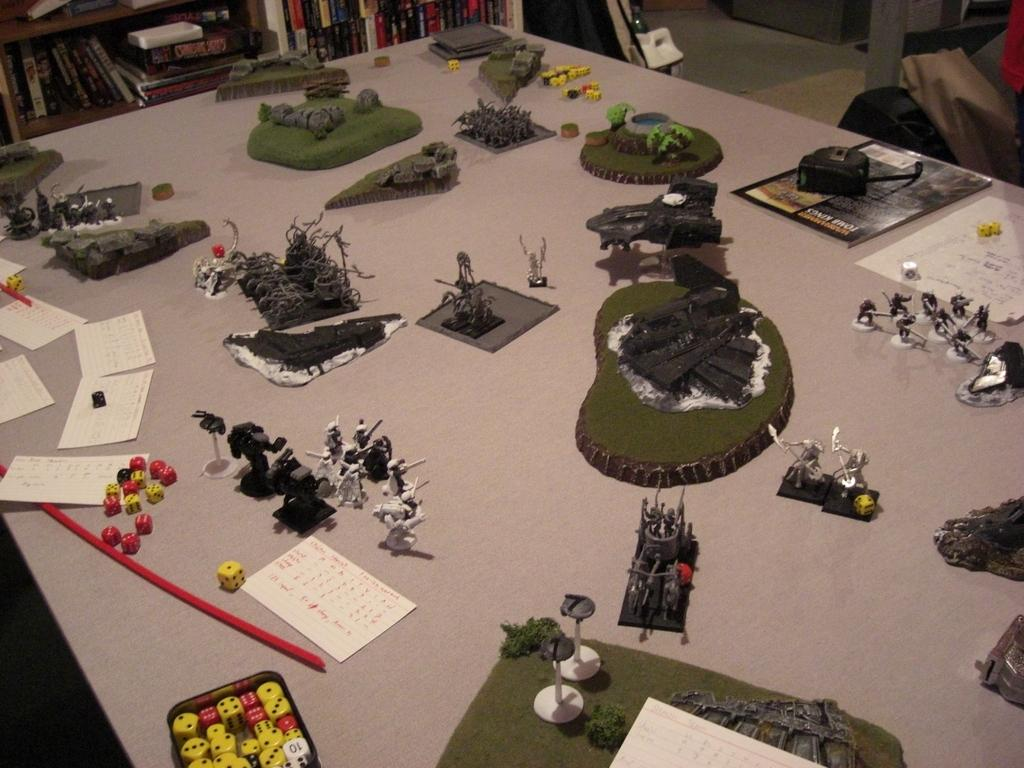What is the primary surface where objects are placed in the image? There are objects placed on a table in the image. What can be seen in the background of the image? There is a bookshelf in the background of the image. How many dogs are sitting on the table in the image? There are no dogs present in the image; it only shows objects placed on a table. 